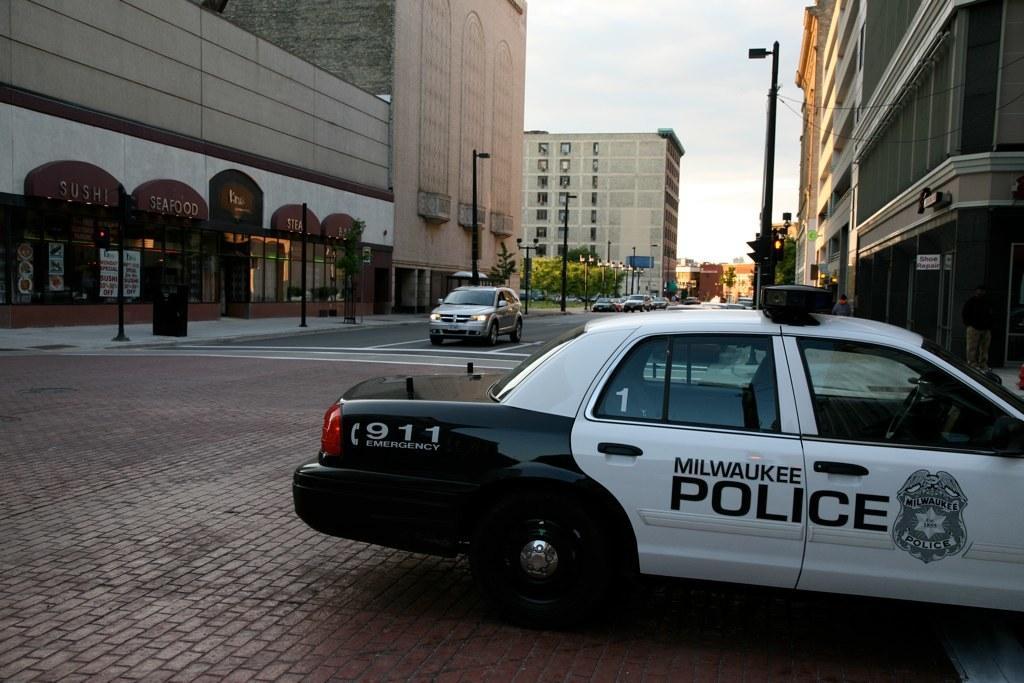Can you describe this image briefly? In this picture there is a car in the right side of the image, there are buildings and poles on the left and right side of the image, it seems to be the road side view. 